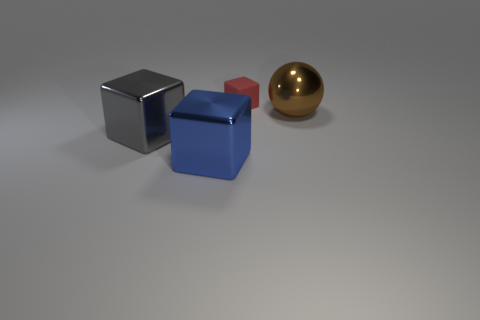Subtract 1 blocks. How many blocks are left? 2 Add 3 tiny green matte objects. How many objects exist? 7 Subtract 0 red cylinders. How many objects are left? 4 Subtract all cubes. How many objects are left? 1 Subtract all large things. Subtract all small yellow blocks. How many objects are left? 1 Add 2 big brown spheres. How many big brown spheres are left? 3 Add 3 purple cubes. How many purple cubes exist? 3 